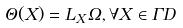<formula> <loc_0><loc_0><loc_500><loc_500>\Theta ( X ) = L _ { X } \Omega , \forall X \in \Gamma D</formula> 